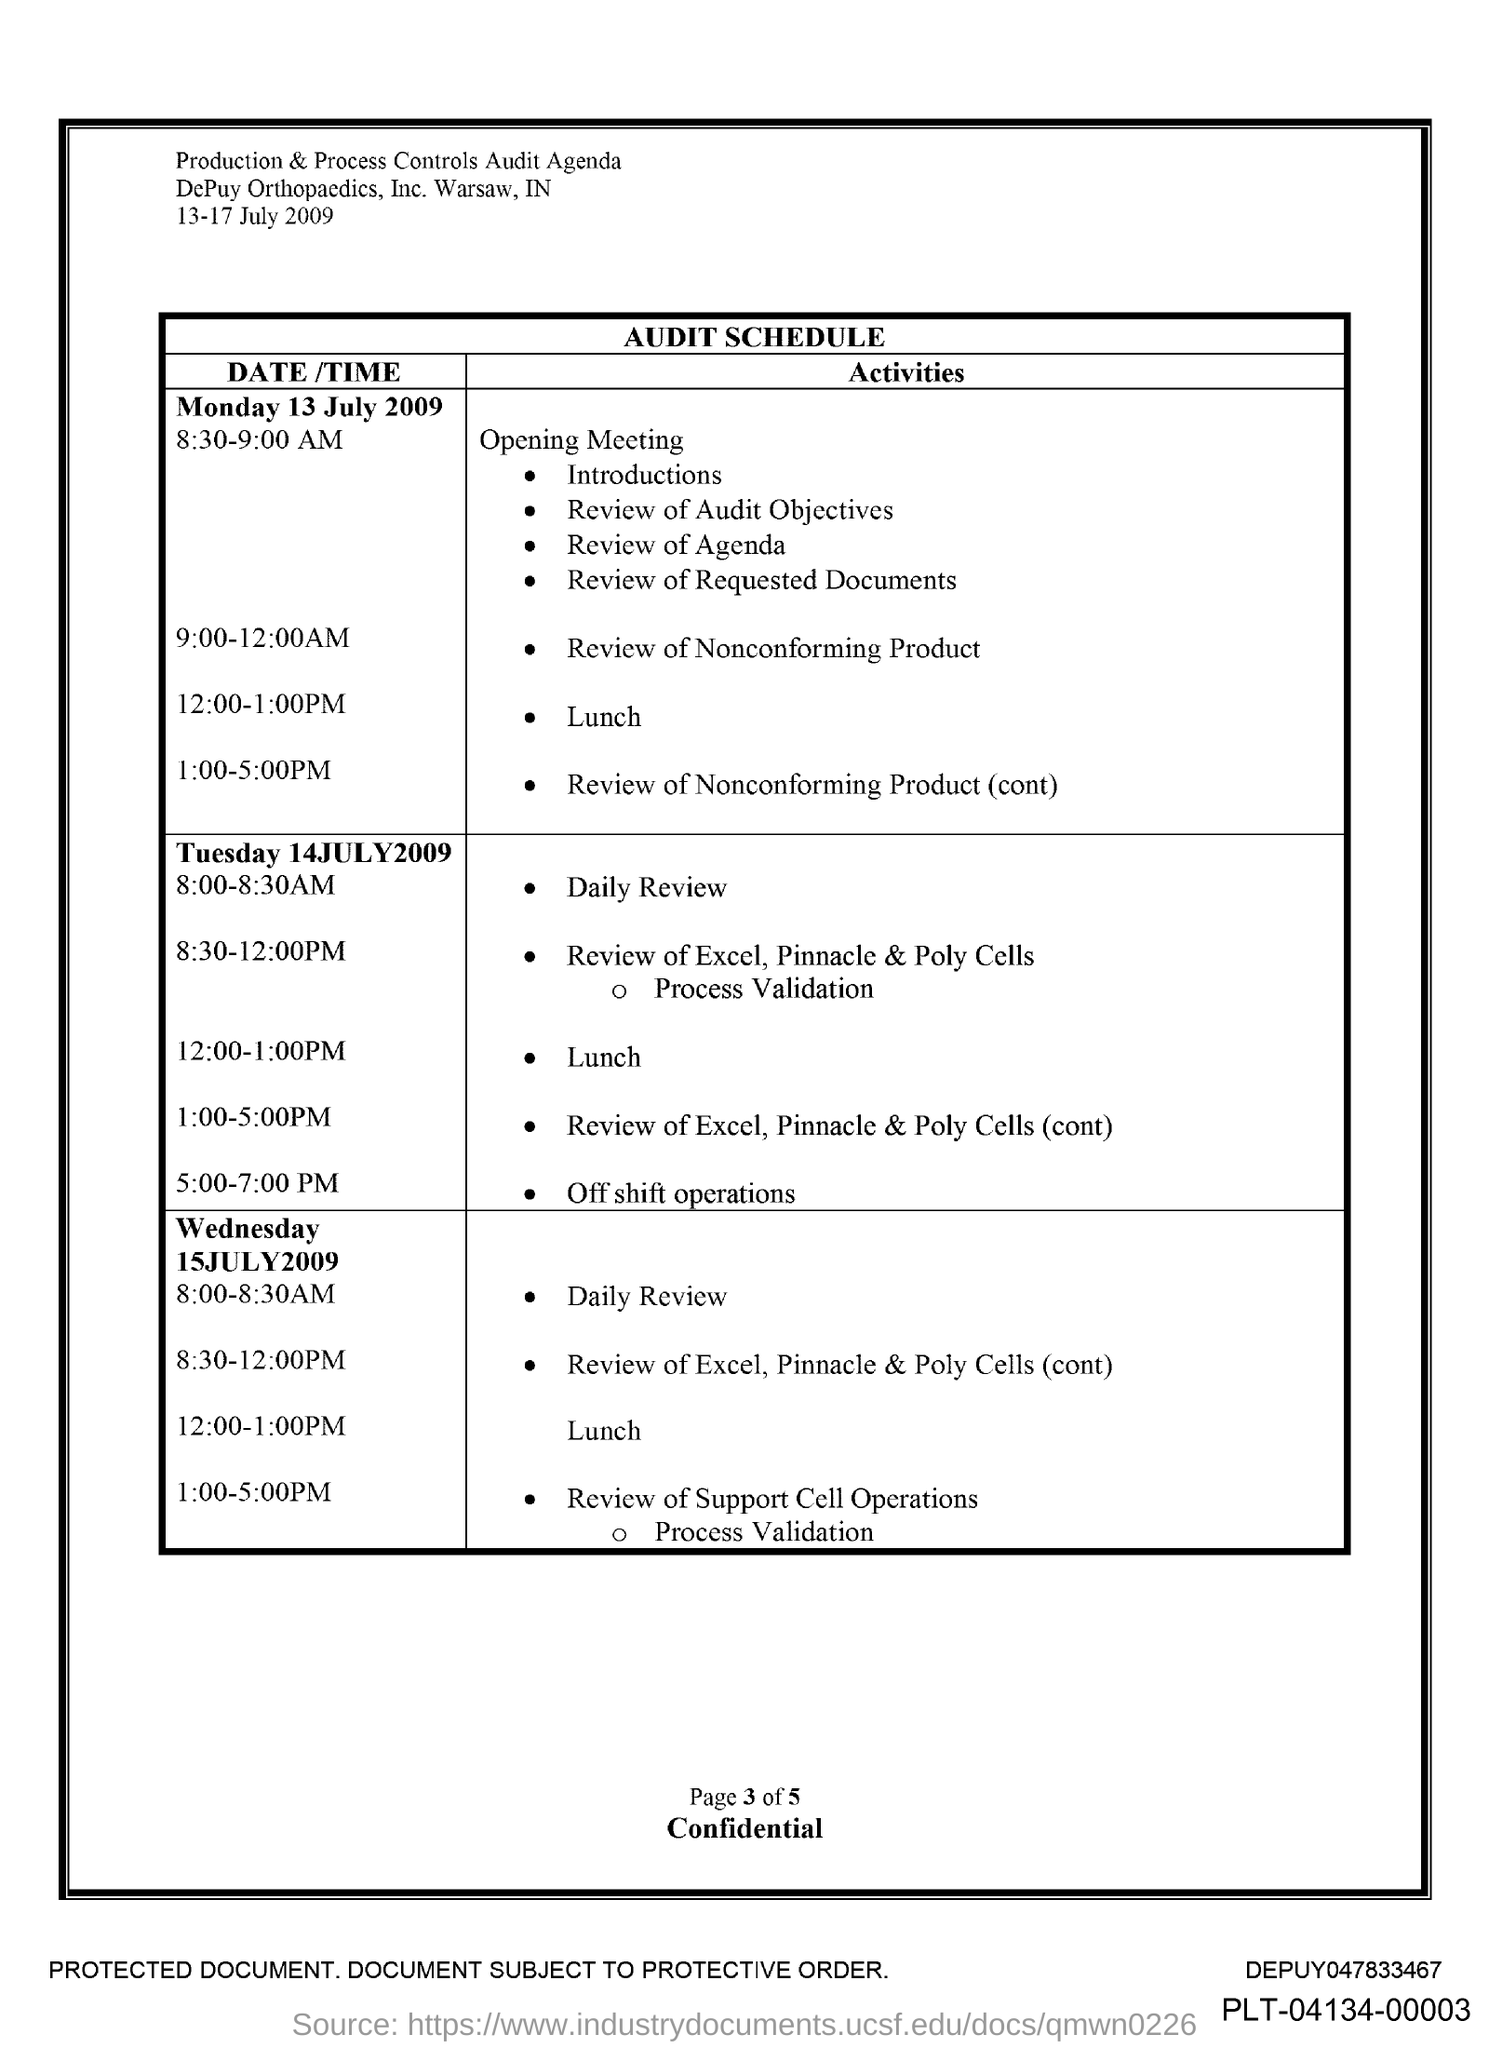Identify some key points in this picture. What is the time for lunch on Monday, July 13, 2009, between 12:00 and 1:00 PM? On Tuesday, July 14, 2009, the time for the daily review is from 8:00-8:30 AM. 